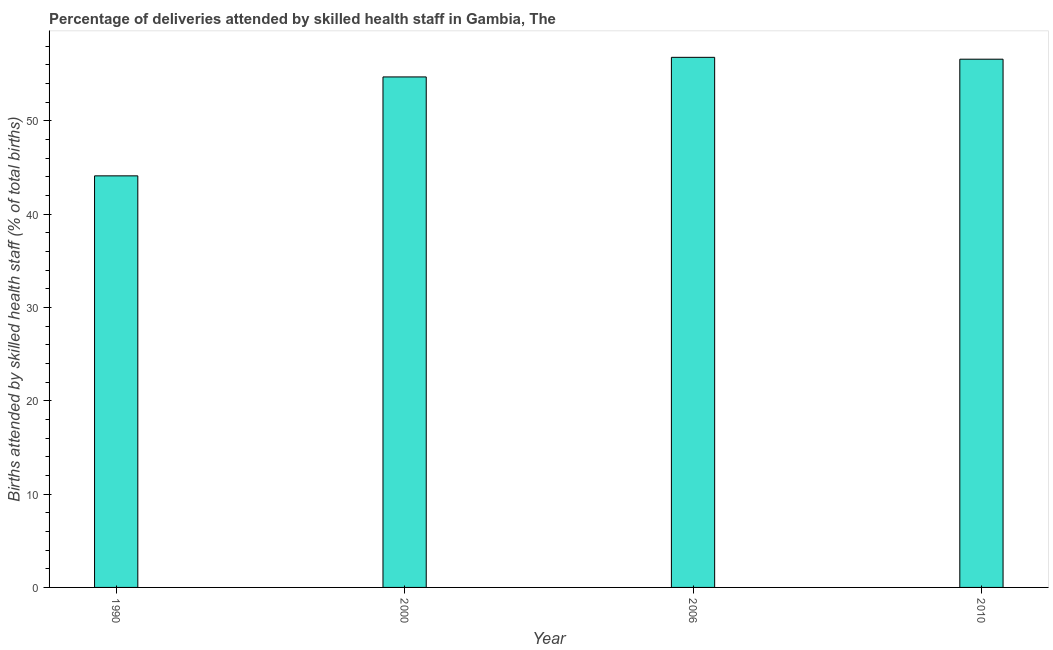Does the graph contain any zero values?
Provide a succinct answer. No. Does the graph contain grids?
Provide a short and direct response. No. What is the title of the graph?
Your response must be concise. Percentage of deliveries attended by skilled health staff in Gambia, The. What is the label or title of the Y-axis?
Provide a short and direct response. Births attended by skilled health staff (% of total births). What is the number of births attended by skilled health staff in 2000?
Provide a short and direct response. 54.7. Across all years, what is the maximum number of births attended by skilled health staff?
Ensure brevity in your answer.  56.8. Across all years, what is the minimum number of births attended by skilled health staff?
Ensure brevity in your answer.  44.1. In which year was the number of births attended by skilled health staff maximum?
Your answer should be very brief. 2006. In which year was the number of births attended by skilled health staff minimum?
Your response must be concise. 1990. What is the sum of the number of births attended by skilled health staff?
Your response must be concise. 212.2. What is the difference between the number of births attended by skilled health staff in 2000 and 2006?
Give a very brief answer. -2.1. What is the average number of births attended by skilled health staff per year?
Keep it short and to the point. 53.05. What is the median number of births attended by skilled health staff?
Give a very brief answer. 55.65. What is the ratio of the number of births attended by skilled health staff in 1990 to that in 2010?
Provide a succinct answer. 0.78. Is the number of births attended by skilled health staff in 1990 less than that in 2010?
Give a very brief answer. Yes. What is the difference between the highest and the second highest number of births attended by skilled health staff?
Offer a terse response. 0.2. Is the sum of the number of births attended by skilled health staff in 2006 and 2010 greater than the maximum number of births attended by skilled health staff across all years?
Your response must be concise. Yes. How many bars are there?
Provide a short and direct response. 4. Are all the bars in the graph horizontal?
Keep it short and to the point. No. What is the Births attended by skilled health staff (% of total births) of 1990?
Give a very brief answer. 44.1. What is the Births attended by skilled health staff (% of total births) of 2000?
Your answer should be very brief. 54.7. What is the Births attended by skilled health staff (% of total births) of 2006?
Make the answer very short. 56.8. What is the Births attended by skilled health staff (% of total births) of 2010?
Offer a terse response. 56.6. What is the difference between the Births attended by skilled health staff (% of total births) in 1990 and 2006?
Offer a very short reply. -12.7. What is the difference between the Births attended by skilled health staff (% of total births) in 1990 and 2010?
Your answer should be very brief. -12.5. What is the difference between the Births attended by skilled health staff (% of total births) in 2000 and 2010?
Ensure brevity in your answer.  -1.9. What is the ratio of the Births attended by skilled health staff (% of total births) in 1990 to that in 2000?
Your answer should be compact. 0.81. What is the ratio of the Births attended by skilled health staff (% of total births) in 1990 to that in 2006?
Provide a short and direct response. 0.78. What is the ratio of the Births attended by skilled health staff (% of total births) in 1990 to that in 2010?
Your answer should be compact. 0.78. What is the ratio of the Births attended by skilled health staff (% of total births) in 2006 to that in 2010?
Your response must be concise. 1. 